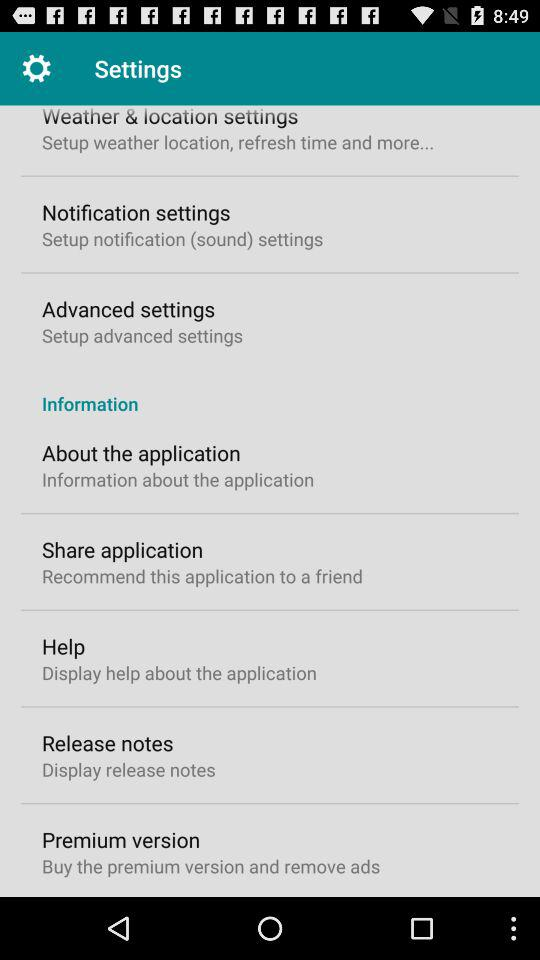How many items are in the first section of the settings menu?
Answer the question using a single word or phrase. 3 